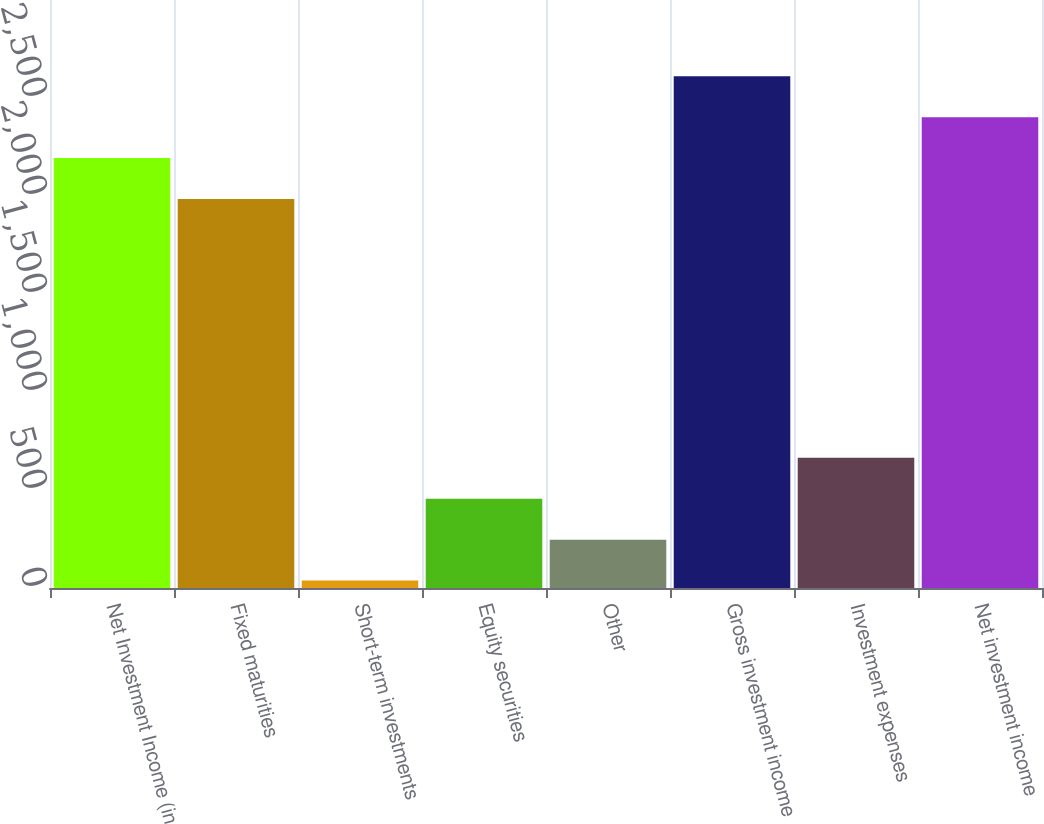Convert chart to OTSL. <chart><loc_0><loc_0><loc_500><loc_500><bar_chart><fcel>Net Investment Income (in<fcel>Fixed maturities<fcel>Short-term investments<fcel>Equity securities<fcel>Other<fcel>Gross investment income<fcel>Investment expenses<fcel>Net investment income<nl><fcel>2193.7<fcel>1985<fcel>38<fcel>455.4<fcel>246.7<fcel>2611.1<fcel>664.1<fcel>2402.4<nl></chart> 